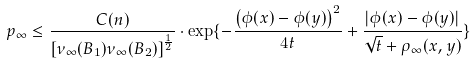<formula> <loc_0><loc_0><loc_500><loc_500>p _ { \infty } \leq \frac { C ( n ) } { \left [ \nu _ { \infty } ( B _ { 1 } ) \nu _ { \infty } ( B _ { 2 } ) \right ] ^ { \frac { 1 } { 2 } } } \cdot \exp \{ - \frac { \left ( \phi ( x ) - \phi ( y ) \right ) ^ { 2 } } { 4 t } + \frac { | \phi ( x ) - \phi ( y ) | } { \sqrt { t } + \rho _ { \infty } ( x , y ) } \}</formula> 